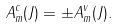Convert formula to latex. <formula><loc_0><loc_0><loc_500><loc_500>A _ { m } ^ { c } ( J ) = \pm A _ { m } ^ { v } ( J ) .</formula> 